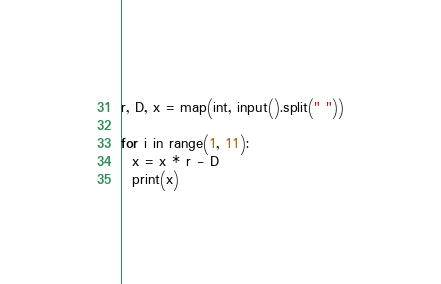Convert code to text. <code><loc_0><loc_0><loc_500><loc_500><_Python_>r, D, x = map(int, input().split(" "))

for i in range(1, 11):
  x = x * r - D
  print(x)</code> 